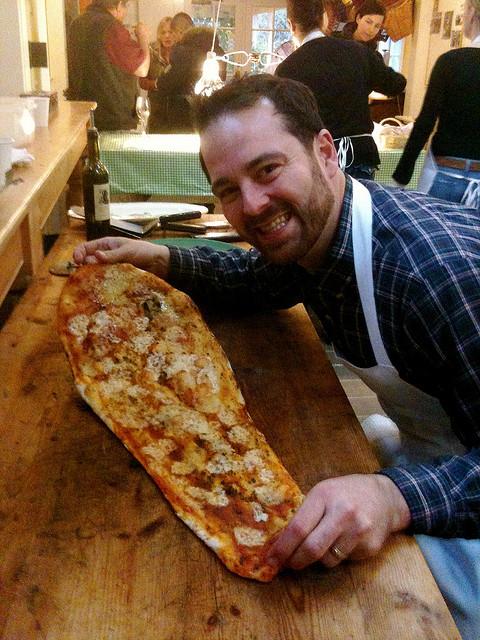Is the person a pro eating champion?
Answer briefly. No. How many people are in this picture?
Be succinct. 7. What is the table made of?
Answer briefly. Wood. 